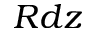Convert formula to latex. <formula><loc_0><loc_0><loc_500><loc_500>R d z</formula> 